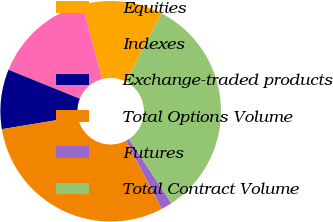<chart> <loc_0><loc_0><loc_500><loc_500><pie_chart><fcel>Equities<fcel>Indexes<fcel>Exchange-traded products<fcel>Total Options Volume<fcel>Futures<fcel>Total Contract Volume<nl><fcel>11.75%<fcel>14.75%<fcel>8.74%<fcel>30.07%<fcel>1.61%<fcel>33.08%<nl></chart> 